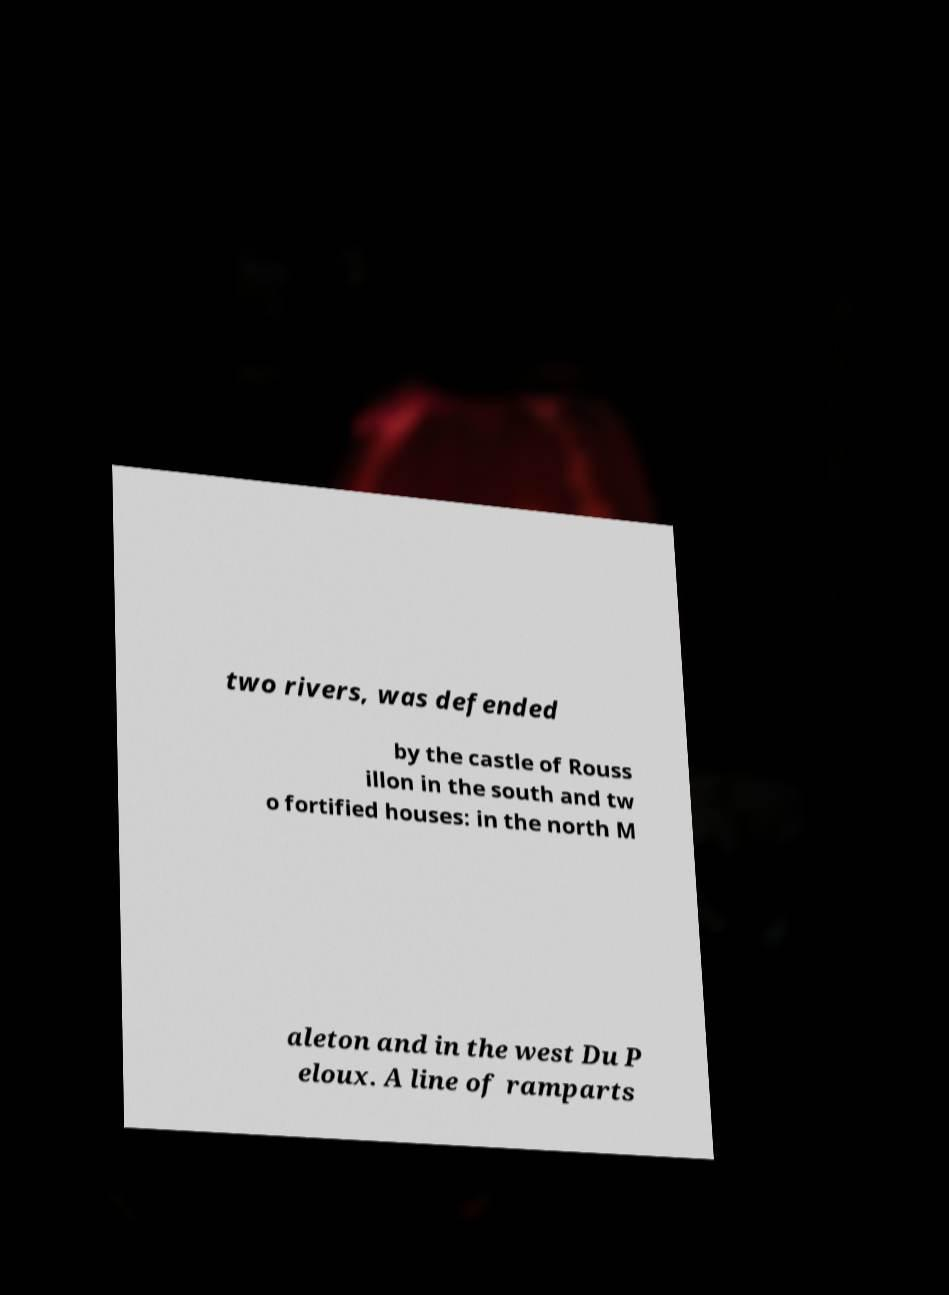There's text embedded in this image that I need extracted. Can you transcribe it verbatim? two rivers, was defended by the castle of Rouss illon in the south and tw o fortified houses: in the north M aleton and in the west Du P eloux. A line of ramparts 